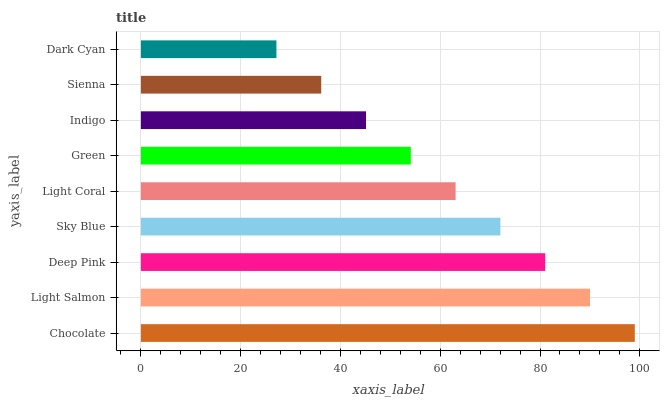Is Dark Cyan the minimum?
Answer yes or no. Yes. Is Chocolate the maximum?
Answer yes or no. Yes. Is Light Salmon the minimum?
Answer yes or no. No. Is Light Salmon the maximum?
Answer yes or no. No. Is Chocolate greater than Light Salmon?
Answer yes or no. Yes. Is Light Salmon less than Chocolate?
Answer yes or no. Yes. Is Light Salmon greater than Chocolate?
Answer yes or no. No. Is Chocolate less than Light Salmon?
Answer yes or no. No. Is Light Coral the high median?
Answer yes or no. Yes. Is Light Coral the low median?
Answer yes or no. Yes. Is Deep Pink the high median?
Answer yes or no. No. Is Light Salmon the low median?
Answer yes or no. No. 